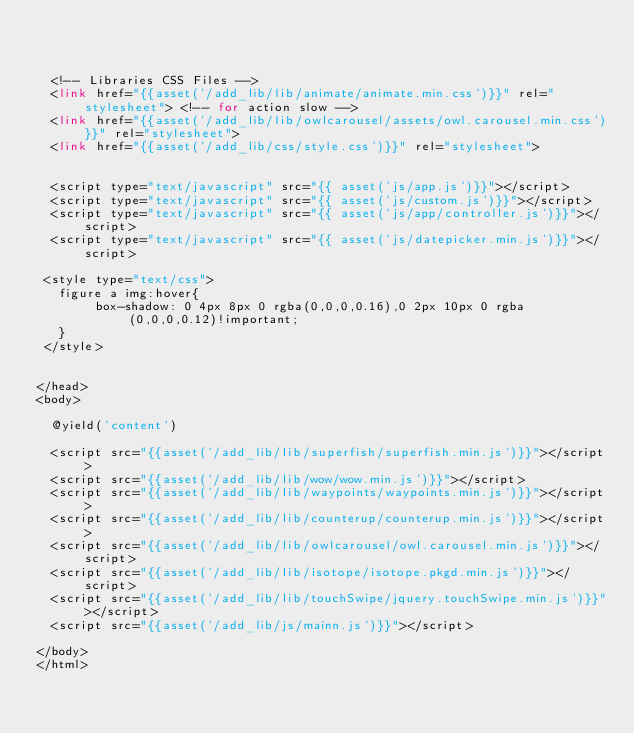<code> <loc_0><loc_0><loc_500><loc_500><_PHP_>


  <!-- Libraries CSS Files -->
  <link href="{{asset('/add_lib/lib/animate/animate.min.css')}}" rel="stylesheet"> <!-- for action slow -->
  <link href="{{asset('/add_lib/lib/owlcarousel/assets/owl.carousel.min.css')}}" rel="stylesheet">
  <link href="{{asset('/add_lib/css/style.css')}}" rel="stylesheet">


	<script type="text/javascript" src="{{ asset('js/app.js')}}"></script>
	<script type="text/javascript" src="{{ asset('js/custom.js')}}"></script>
  <script type="text/javascript" src="{{ asset('js/app/controller.js')}}"></script>
	<script type="text/javascript" src="{{ asset('js/datepicker.min.js')}}"></script>

 <style type="text/css">
   figure a img:hover{
        box-shadow: 0 4px 8px 0 rgba(0,0,0,0.16),0 2px 10px 0 rgba(0,0,0,0.12)!important;
   }
 </style>


</head>
<body>
  
	@yield('content')  
 
  <script src="{{asset('/add_lib/lib/superfish/superfish.min.js')}}"></script>
  <script src="{{asset('/add_lib/lib/wow/wow.min.js')}}"></script>
  <script src="{{asset('/add_lib/lib/waypoints/waypoints.min.js')}}"></script>
  <script src="{{asset('/add_lib/lib/counterup/counterup.min.js')}}"></script>
  <script src="{{asset('/add_lib/lib/owlcarousel/owl.carousel.min.js')}}"></script>
  <script src="{{asset('/add_lib/lib/isotope/isotope.pkgd.min.js')}}"></script>  
  <script src="{{asset('/add_lib/lib/touchSwipe/jquery.touchSwipe.min.js')}}"></script>
  <script src="{{asset('/add_lib/js/mainn.js')}}"></script>

</body>
</html></code> 